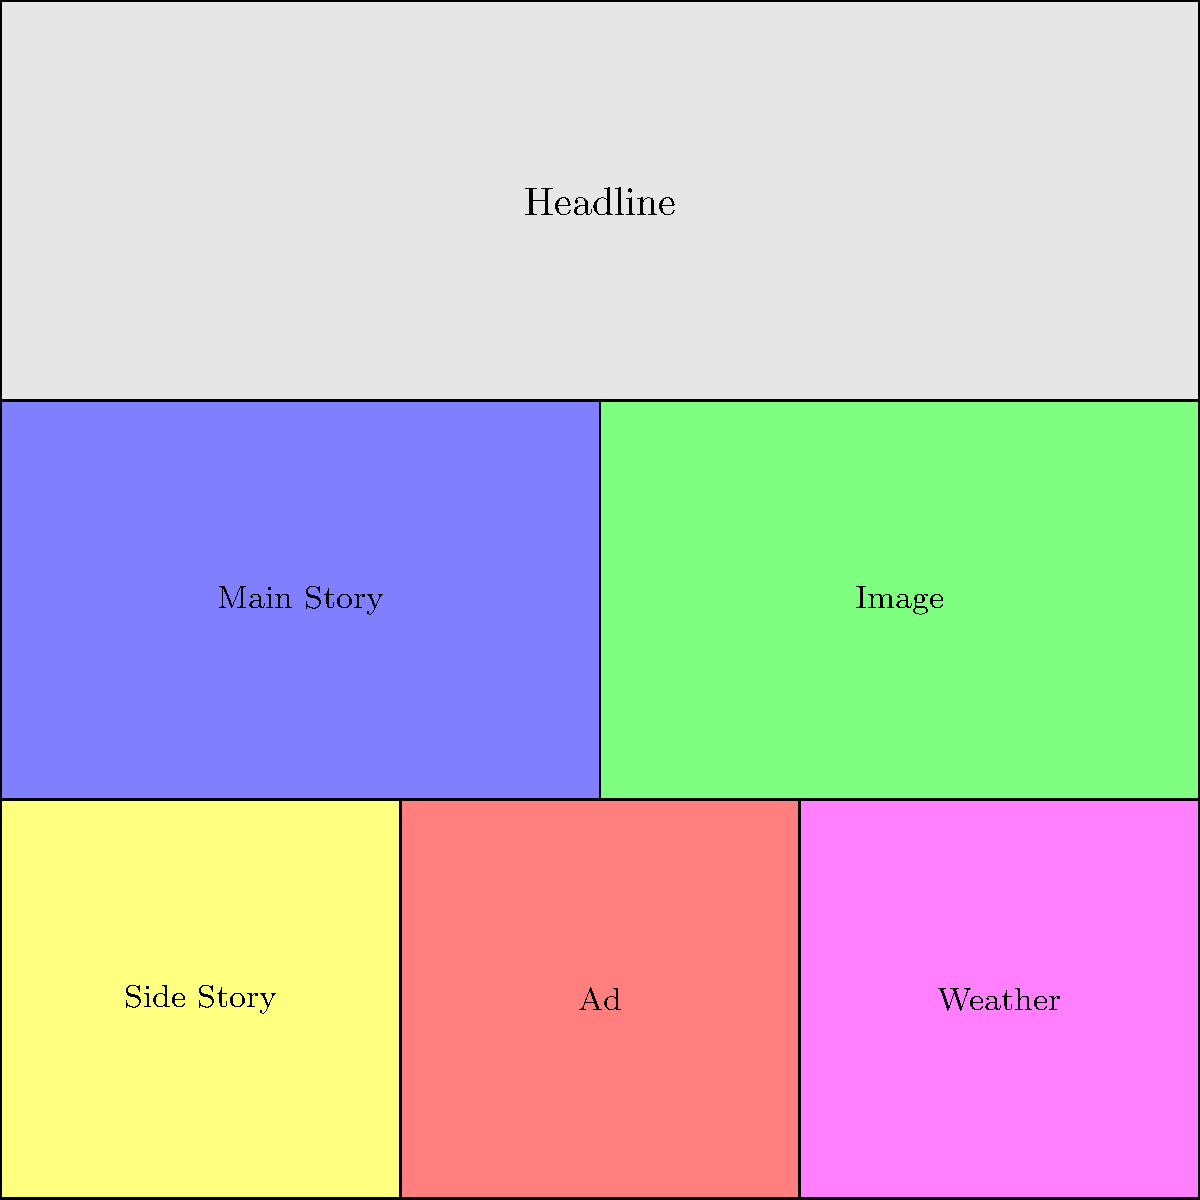Analyze the layout of this newspaper front page using the grid overlay. What fraction of the total page area does the main story occupy? To determine the fraction of the total page area occupied by the main story, we need to follow these steps:

1. Count the total number of grid squares on the page:
   The grid is 6 squares wide and 6 squares tall, so the total area is 6 × 6 = 36 squares.

2. Identify the main story area:
   The main story is located in the upper-left quadrant of the page, below the headline.

3. Count the number of squares occupied by the main story:
   The main story occupies a rectangle that is 3 squares wide and 2 squares tall.
   Area of main story = 3 × 2 = 6 squares

4. Calculate the fraction:
   Fraction = (Area of main story) / (Total page area)
   Fraction = 6 / 36

5. Simplify the fraction:
   6/36 can be reduced by dividing both the numerator and denominator by their greatest common divisor (6).
   (6 ÷ 6) / (36 ÷ 6) = 1/6

Therefore, the main story occupies 1/6 of the total page area.
Answer: 1/6 